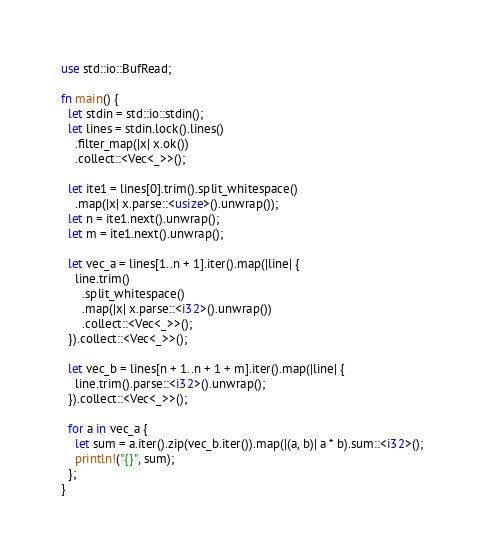Convert code to text. <code><loc_0><loc_0><loc_500><loc_500><_Rust_>use std::io::BufRead;

fn main() {
  let stdin = std::io::stdin();
  let lines = stdin.lock().lines()
    .filter_map(|x| x.ok())
    .collect::<Vec<_>>();

  let ite1 = lines[0].trim().split_whitespace()
    .map(|x| x.parse::<usize>().unwrap());
  let n = ite1.next().unwrap();
  let m = ite1.next().unwrap();

  let vec_a = lines[1..n + 1].iter().map(|line| {
    line.trim()
      .split_whitespace()
      .map(|x| x.parse::<i32>().unwrap())
      .collect::<Vec<_>>();
  }).collect::<Vec<_>>();

  let vec_b = lines[n + 1..n + 1 + m].iter().map(|line| {
    line.trim().parse::<i32>().unwrap();
  }).collect::<Vec<_>>();

  for a in vec_a {
    let sum = a.iter().zip(vec_b.iter()).map(|(a, b)| a * b).sum::<i32>();
    println!("{}", sum);
  };
}
</code> 